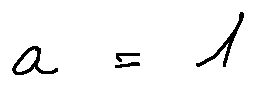<formula> <loc_0><loc_0><loc_500><loc_500>\alpha = 1</formula> 